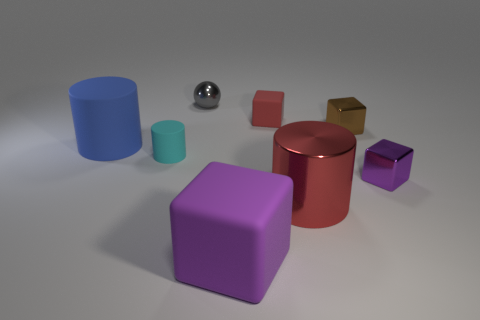Is the size of the gray metallic object that is to the left of the brown metallic thing the same as the purple matte block?
Offer a very short reply. No. What number of tiny purple matte balls are there?
Offer a very short reply. 0. How many matte things are both on the right side of the large blue matte cylinder and behind the large red shiny object?
Your answer should be very brief. 2. Is there a cylinder that has the same material as the big red object?
Make the answer very short. No. What is the material of the thing that is behind the cube that is behind the tiny brown object?
Your answer should be compact. Metal. Are there the same number of matte cubes left of the large purple block and small red blocks that are on the right side of the red cylinder?
Your answer should be very brief. Yes. Is the brown shiny object the same shape as the gray thing?
Keep it short and to the point. No. What material is the cube that is behind the big red metal cylinder and in front of the small cylinder?
Give a very brief answer. Metal. What number of other red matte things have the same shape as the small red rubber thing?
Provide a short and direct response. 0. There is a red object in front of the small matte thing in front of the large thing that is behind the cyan cylinder; what size is it?
Ensure brevity in your answer.  Large. 